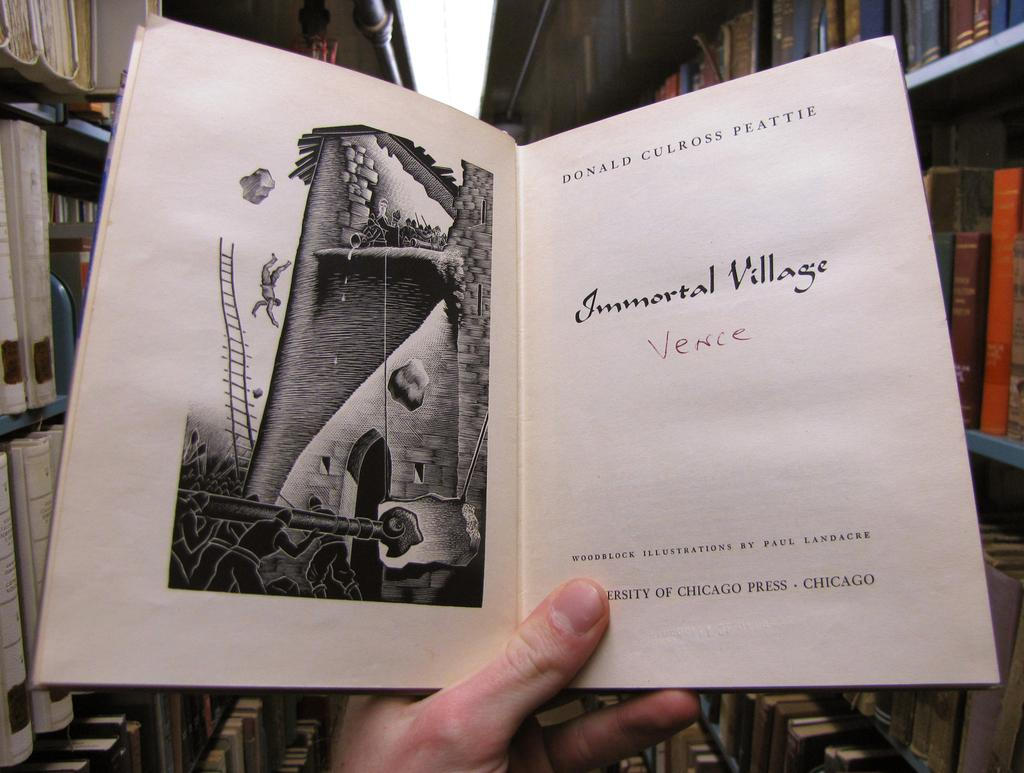<image>
Share a concise interpretation of the image provided. A person holding a book titled Immortal Village: Venice and written by Donald Culross Peattie. 